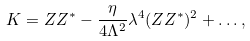<formula> <loc_0><loc_0><loc_500><loc_500>K = Z Z ^ { * } - \frac { \eta } { 4 \Lambda ^ { 2 } } \lambda ^ { 4 } ( Z Z ^ { * } ) ^ { 2 } + \dots ,</formula> 